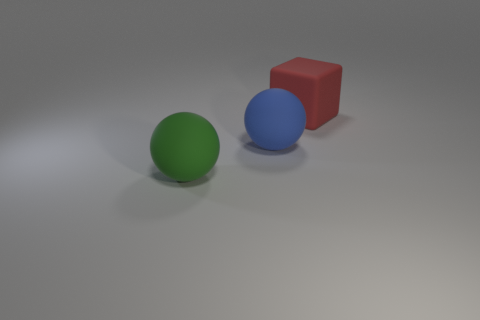Is there anything else that has the same material as the green sphere?
Offer a very short reply. Yes. What is the shape of the red object that is the same size as the blue thing?
Make the answer very short. Cube. What number of red matte blocks are behind the rubber object that is on the left side of the large ball right of the green ball?
Give a very brief answer. 1. Are there more large objects behind the large green sphere than green matte objects that are behind the blue rubber sphere?
Keep it short and to the point. Yes. What number of big blue rubber things are the same shape as the green thing?
Provide a succinct answer. 1. How many objects are matte things in front of the big red rubber thing or large objects that are to the left of the big blue ball?
Your answer should be very brief. 2. The large ball that is in front of the ball right of the large matte thing left of the blue ball is made of what material?
Provide a succinct answer. Rubber. Are there any green spheres that have the same size as the blue matte thing?
Offer a very short reply. Yes. What number of large blue spheres are there?
Your answer should be very brief. 1. What number of large green objects are in front of the matte block?
Your response must be concise. 1. 